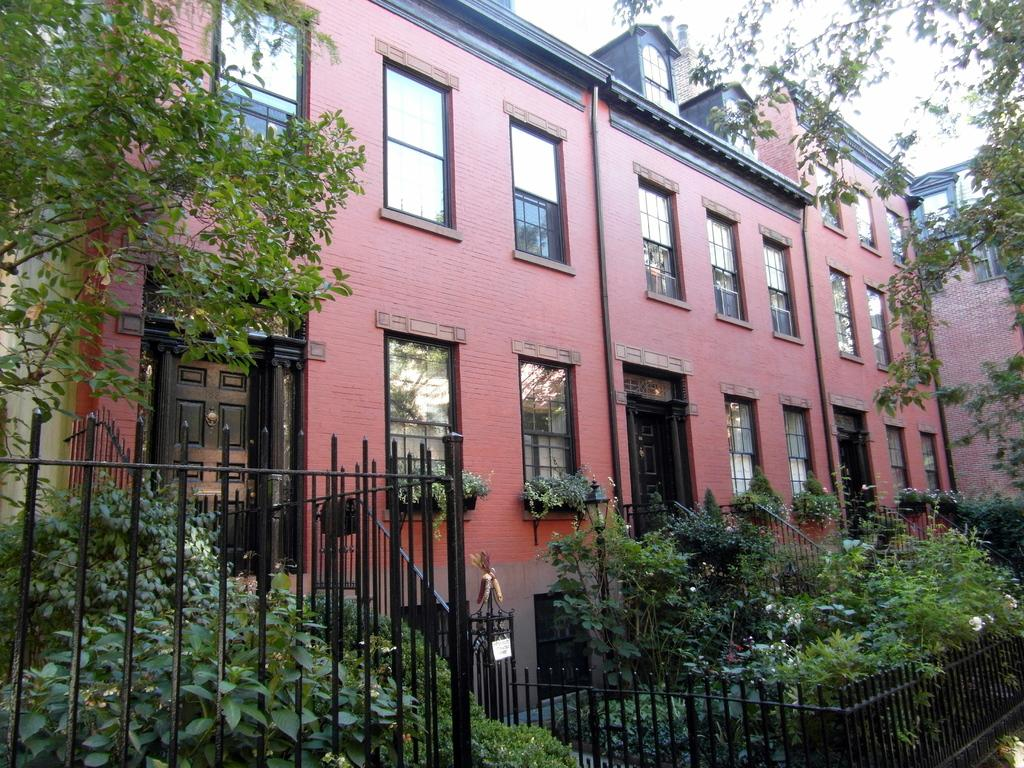What type of structures can be seen in the image? There are buildings in the image. What are the pipelines used for in the image? The purpose of the pipelines is not specified in the image. What architectural features are visible in the image? Windows, doors, and iron grills are visible in the image. What type of vegetation is present in the image? Plants and trees are visible in the image. What part of the natural environment is visible in the image? The sky is visible in the image. How many chickens are visible in the image? There are no chickens present in the image. What type of test is being conducted in the image? There is no indication of a test being conducted in the image. 